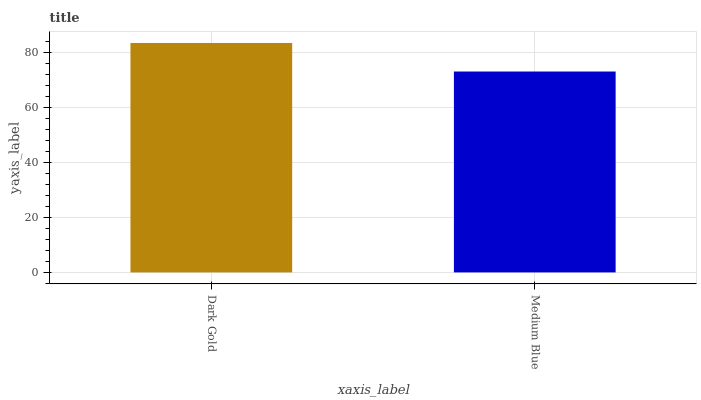Is Medium Blue the minimum?
Answer yes or no. Yes. Is Dark Gold the maximum?
Answer yes or no. Yes. Is Medium Blue the maximum?
Answer yes or no. No. Is Dark Gold greater than Medium Blue?
Answer yes or no. Yes. Is Medium Blue less than Dark Gold?
Answer yes or no. Yes. Is Medium Blue greater than Dark Gold?
Answer yes or no. No. Is Dark Gold less than Medium Blue?
Answer yes or no. No. Is Dark Gold the high median?
Answer yes or no. Yes. Is Medium Blue the low median?
Answer yes or no. Yes. Is Medium Blue the high median?
Answer yes or no. No. Is Dark Gold the low median?
Answer yes or no. No. 